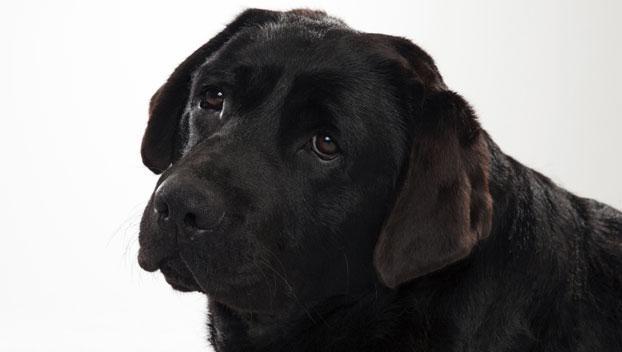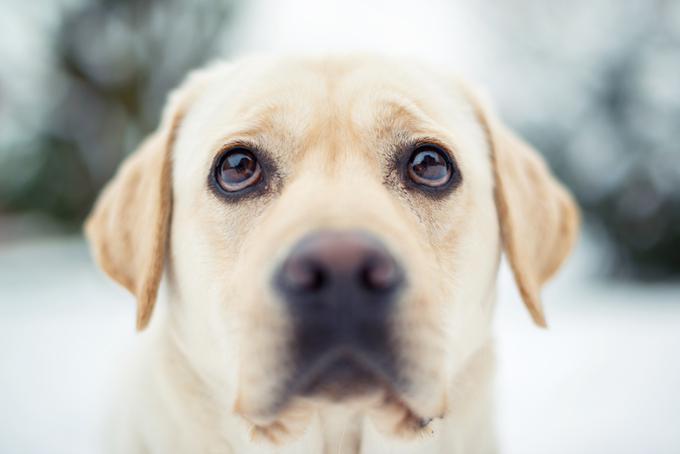The first image is the image on the left, the second image is the image on the right. For the images shown, is this caption "There are two dogs in the image on the right." true? Answer yes or no. No. 